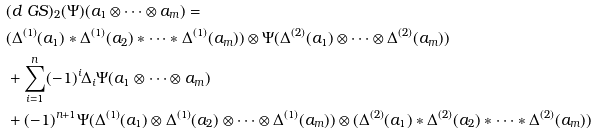Convert formula to latex. <formula><loc_0><loc_0><loc_500><loc_500>\ & ( d _ { \ } G S ) _ { 2 } ( \Psi ) ( a _ { 1 } \otimes \dots \otimes a _ { m } ) = \\ & ( \Delta ^ { ( 1 ) } ( a _ { 1 } ) * \Delta ^ { ( 1 ) } ( a _ { 2 } ) * \dots * \Delta ^ { ( 1 ) } ( a _ { m } ) ) \otimes \Psi ( \Delta ^ { ( 2 ) } ( a _ { 1 } ) \otimes \dots \otimes \Delta ^ { ( 2 ) } ( a _ { m } ) ) \\ & + \sum _ { i = 1 } ^ { n } ( - 1 ) ^ { i } \Delta _ { i } \Psi ( a _ { 1 } \otimes \dots \otimes a _ { m } ) \\ & + ( - 1 ) ^ { n + 1 } \Psi ( \Delta ^ { ( 1 ) } ( a _ { 1 } ) \otimes \Delta ^ { ( 1 ) } ( a _ { 2 } ) \otimes \dots \otimes \Delta ^ { ( 1 ) } ( a _ { m } ) ) \otimes ( \Delta ^ { ( 2 ) } ( a _ { 1 } ) * \Delta ^ { ( 2 ) } ( a _ { 2 } ) * \dots * \Delta ^ { ( 2 ) } ( a _ { m } ) )</formula> 